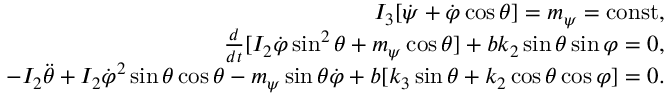<formula> <loc_0><loc_0><loc_500><loc_500>\begin{array} { r } { I _ { 3 } [ \dot { \psi } + \dot { \varphi } \cos \theta ] = m _ { \psi } = c o n s t , } \\ { \frac { d } { d t } [ I _ { 2 } \dot { \varphi } \sin ^ { 2 } \theta + m _ { \psi } \cos \theta ] + b k _ { 2 } \sin \theta \sin \varphi = 0 , } \\ { - I _ { 2 } \ddot { \theta } + I _ { 2 } \dot { \varphi } ^ { 2 } \sin \theta \cos \theta - m _ { \psi } \sin \theta \dot { \varphi } + b [ k _ { 3 } \sin \theta + k _ { 2 } \cos \theta \cos \varphi ] = 0 . } \end{array}</formula> 